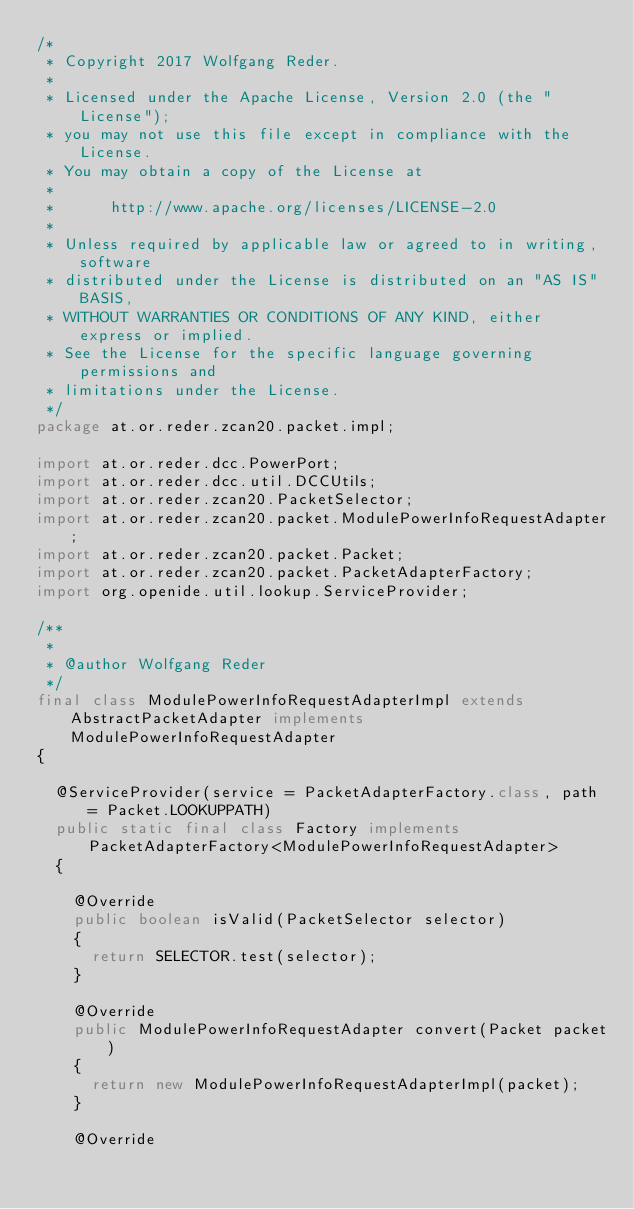Convert code to text. <code><loc_0><loc_0><loc_500><loc_500><_Java_>/*
 * Copyright 2017 Wolfgang Reder.
 *
 * Licensed under the Apache License, Version 2.0 (the "License");
 * you may not use this file except in compliance with the License.
 * You may obtain a copy of the License at
 *
 *      http://www.apache.org/licenses/LICENSE-2.0
 *
 * Unless required by applicable law or agreed to in writing, software
 * distributed under the License is distributed on an "AS IS" BASIS,
 * WITHOUT WARRANTIES OR CONDITIONS OF ANY KIND, either express or implied.
 * See the License for the specific language governing permissions and
 * limitations under the License.
 */
package at.or.reder.zcan20.packet.impl;

import at.or.reder.dcc.PowerPort;
import at.or.reder.dcc.util.DCCUtils;
import at.or.reder.zcan20.PacketSelector;
import at.or.reder.zcan20.packet.ModulePowerInfoRequestAdapter;
import at.or.reder.zcan20.packet.Packet;
import at.or.reder.zcan20.packet.PacketAdapterFactory;
import org.openide.util.lookup.ServiceProvider;

/**
 *
 * @author Wolfgang Reder
 */
final class ModulePowerInfoRequestAdapterImpl extends AbstractPacketAdapter implements ModulePowerInfoRequestAdapter
{

  @ServiceProvider(service = PacketAdapterFactory.class, path = Packet.LOOKUPPATH)
  public static final class Factory implements PacketAdapterFactory<ModulePowerInfoRequestAdapter>
  {

    @Override
    public boolean isValid(PacketSelector selector)
    {
      return SELECTOR.test(selector);
    }

    @Override
    public ModulePowerInfoRequestAdapter convert(Packet packet)
    {
      return new ModulePowerInfoRequestAdapterImpl(packet);
    }

    @Override</code> 